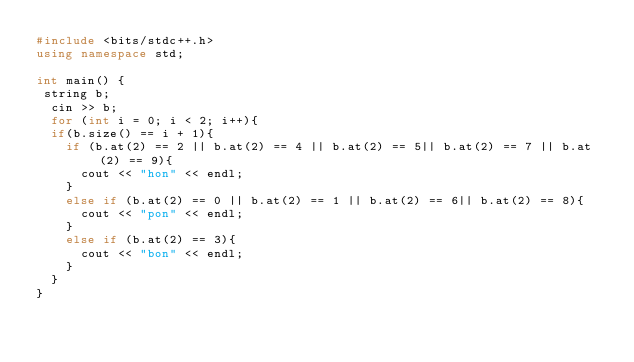<code> <loc_0><loc_0><loc_500><loc_500><_C++_>#include <bits/stdc++.h>
using namespace std;

int main() {
 string b;
  cin >> b;
  for (int i = 0; i < 2; i++){
  if(b.size() == i + 1){
    if (b.at(2) == 2 || b.at(2) == 4 || b.at(2) == 5|| b.at(2) == 7 || b.at(2) == 9){
      cout << "hon" << endl;
    }
    else if (b.at(2) == 0 || b.at(2) == 1 || b.at(2) == 6|| b.at(2) == 8){
      cout << "pon" << endl;
    }
    else if (b.at(2) == 3){
      cout << "bon" << endl;
    }
  }
}</code> 